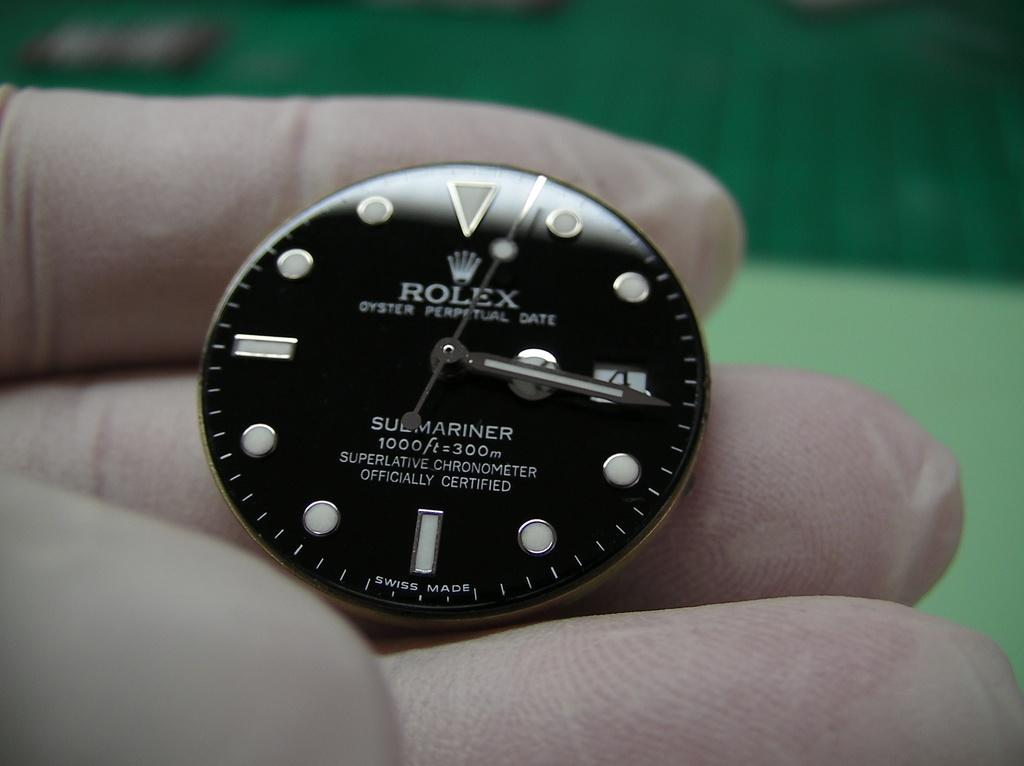<image>
Write a terse but informative summary of the picture. A rolex watch on someone's hand wearing white gloves. 